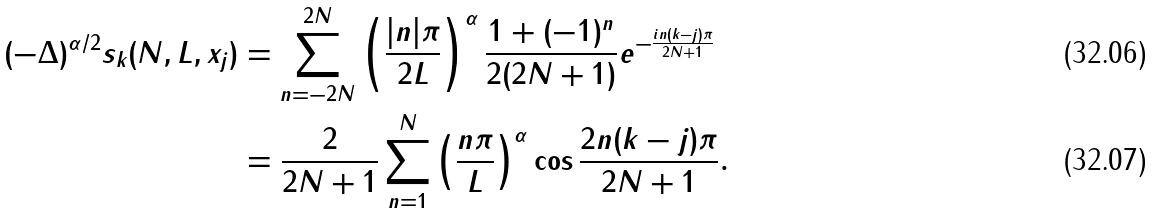<formula> <loc_0><loc_0><loc_500><loc_500>( - \Delta ) ^ { \alpha / 2 } s _ { k } ( N , L , x _ { j } ) & = \sum _ { n = - 2 N } ^ { 2 N } \left ( \frac { | n | \pi } { 2 L } \right ) ^ { \alpha } \frac { 1 + ( - 1 ) ^ { n } } { 2 ( 2 N + 1 ) } e ^ { - \frac { i n ( k - j ) \pi } { 2 N + 1 } } \\ & = \frac { 2 } { 2 N + 1 } \sum _ { n = 1 } ^ { N } \left ( \frac { n \pi } { L } \right ) ^ { \alpha } \cos \frac { 2 n ( k - j ) \pi } { 2 N + 1 } .</formula> 